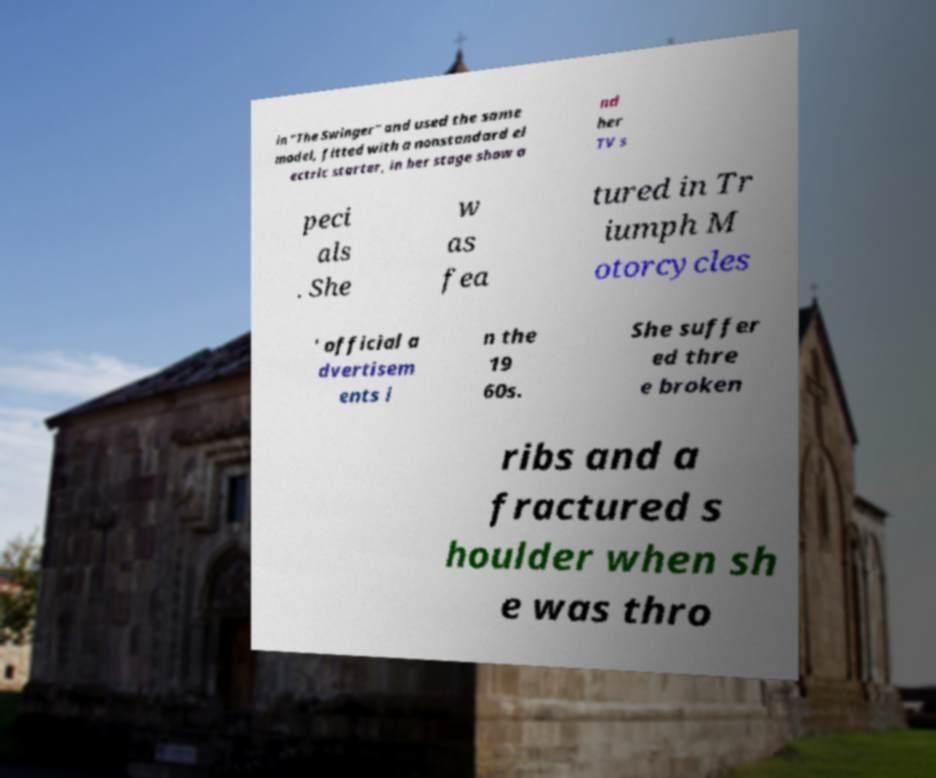I need the written content from this picture converted into text. Can you do that? in "The Swinger" and used the same model, fitted with a nonstandard el ectric starter, in her stage show a nd her TV s peci als . She w as fea tured in Tr iumph M otorcycles ' official a dvertisem ents i n the 19 60s. She suffer ed thre e broken ribs and a fractured s houlder when sh e was thro 